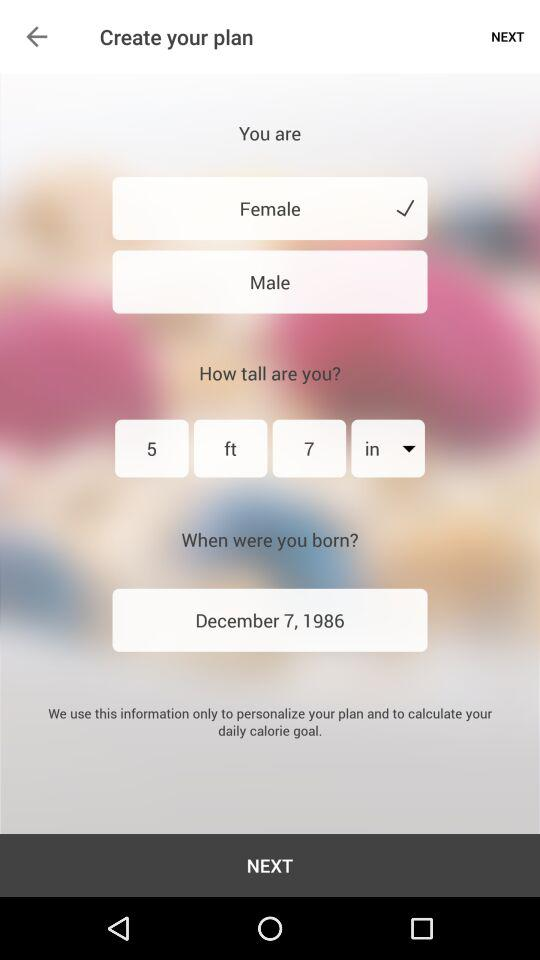What is the height of the person? The height is 5 feet 7 inches. 